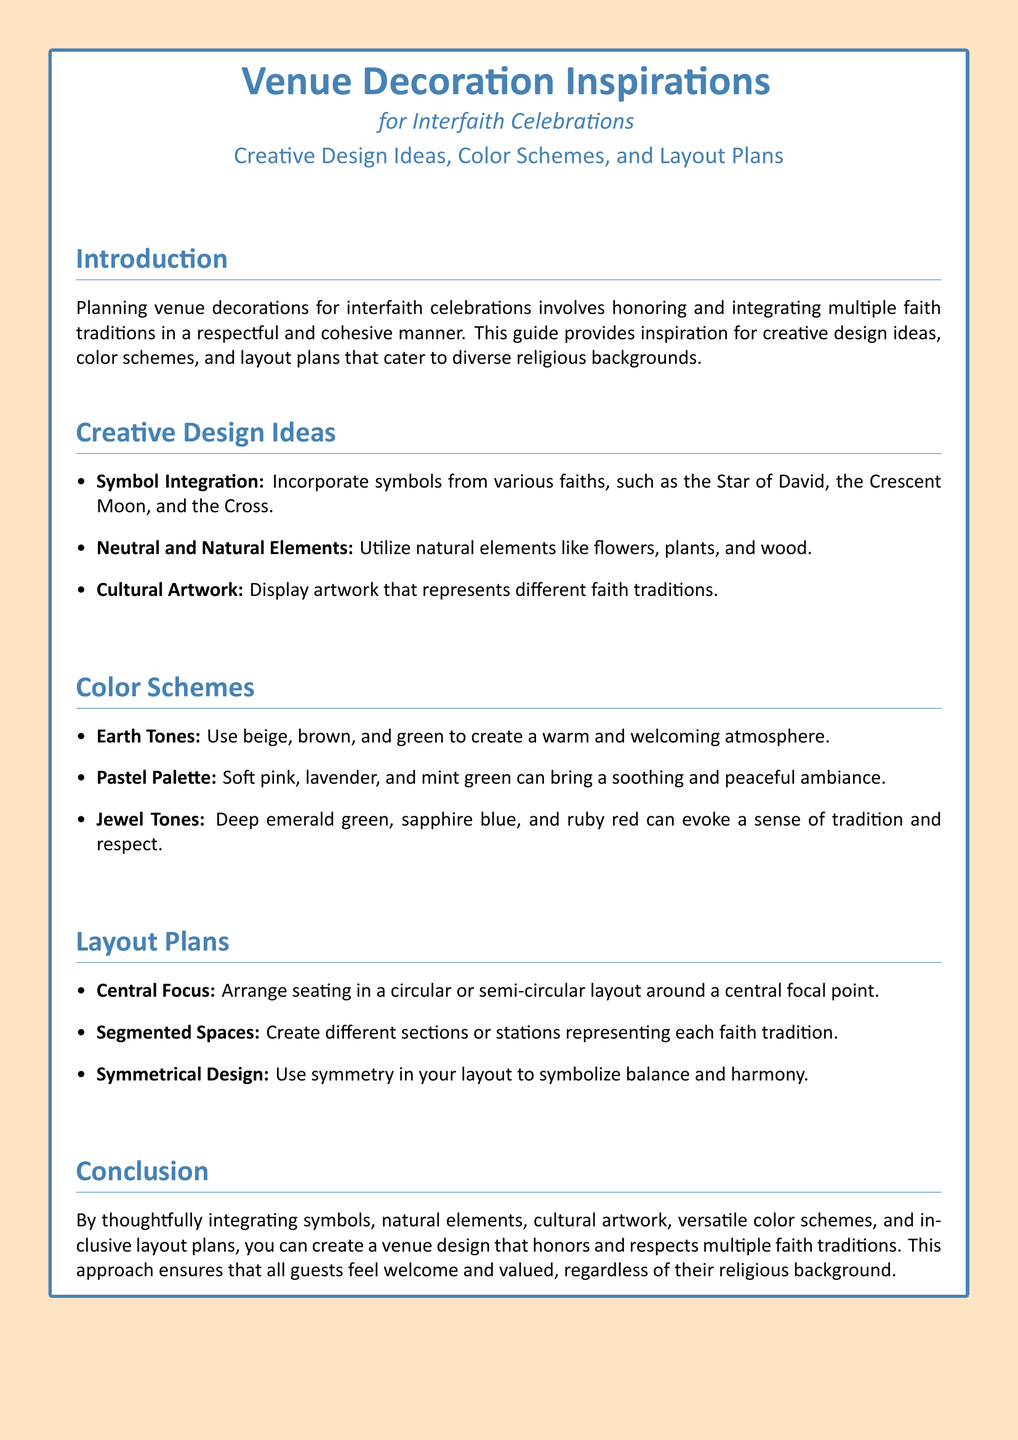What are some symbols mentioned for integration? The section on Creative Design Ideas lists symbols to incorporate for interfaith celebrations, including the Star of David, Crescent Moon, and Cross.
Answer: Star of David, Crescent Moon, Cross What color scheme is suggested for a warm atmosphere? The document specifies that Earth Tones create a warm and welcoming atmosphere in the Color Schemes section.
Answer: Earth Tones What layout style is recommended to symbolize balance? The Layout Plans section mentions that a Symmetrical Design symbolizes balance and harmony.
Answer: Symmetrical Design How many color schemes are provided in the document? The Color Schemes section presents three distinct color schemes used for interfaith event decoration.
Answer: Three What is the main purpose of this guide? The introduction outlines that the purpose of the guide is to provide inspiration for the decoration of venues honoring multiple faith traditions respectfully.
Answer: Inspiration for decoration What element is suggested to represent different faith traditions? The Creative Design Ideas section suggests using Cultural Artwork to represent different faith traditions.
Answer: Cultural Artwork What is the layout arrangement type suggested around a central focal point? The Layout Plans section suggests a circular or semi-circular layout to arrange seating around a central focal point.
Answer: Circular or semi-circular Which color scheme includes deep colors? The document specifies that Jewel Tones consist of deep colors for creating a traditional and respectful feeling.
Answer: Jewel Tones 